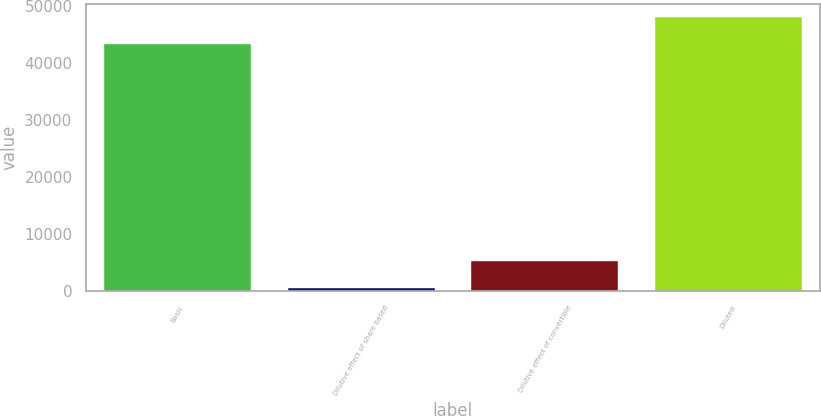Convert chart to OTSL. <chart><loc_0><loc_0><loc_500><loc_500><bar_chart><fcel>Basic<fcel>Dilutive effect of share based<fcel>Dilutive effect of convertible<fcel>Diluted<nl><fcel>43325<fcel>570<fcel>5277.6<fcel>48032.6<nl></chart> 